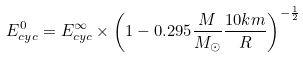<formula> <loc_0><loc_0><loc_500><loc_500>E _ { c y c } ^ { 0 } = E _ { c y c } ^ { \infty } \times \left ( 1 - 0 . 2 9 5 \frac { M } { M _ { \odot } } \frac { 1 0 { k m } } { R } \right ) ^ { - \frac { 1 } { 2 } }</formula> 